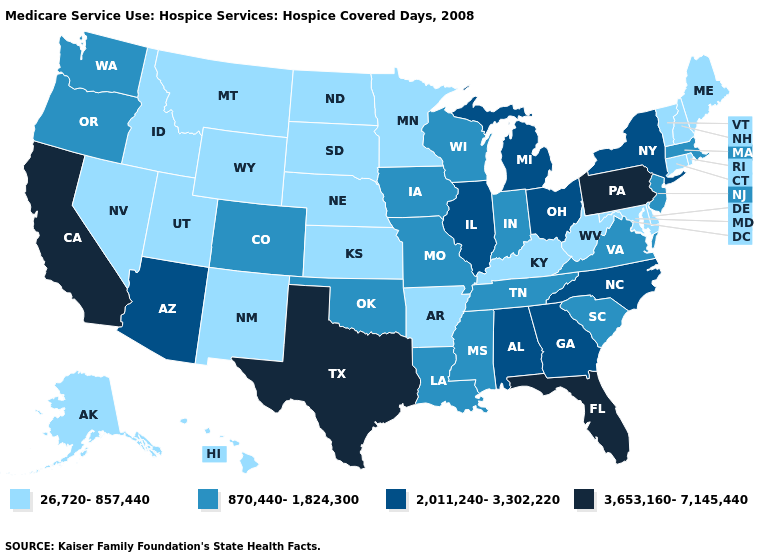Name the states that have a value in the range 26,720-857,440?
Quick response, please. Alaska, Arkansas, Connecticut, Delaware, Hawaii, Idaho, Kansas, Kentucky, Maine, Maryland, Minnesota, Montana, Nebraska, Nevada, New Hampshire, New Mexico, North Dakota, Rhode Island, South Dakota, Utah, Vermont, West Virginia, Wyoming. What is the lowest value in states that border Missouri?
Give a very brief answer. 26,720-857,440. Name the states that have a value in the range 870,440-1,824,300?
Write a very short answer. Colorado, Indiana, Iowa, Louisiana, Massachusetts, Mississippi, Missouri, New Jersey, Oklahoma, Oregon, South Carolina, Tennessee, Virginia, Washington, Wisconsin. What is the value of New Jersey?
Answer briefly. 870,440-1,824,300. Does Mississippi have the lowest value in the USA?
Write a very short answer. No. What is the value of Maryland?
Short answer required. 26,720-857,440. Name the states that have a value in the range 2,011,240-3,302,220?
Concise answer only. Alabama, Arizona, Georgia, Illinois, Michigan, New York, North Carolina, Ohio. Which states have the highest value in the USA?
Keep it brief. California, Florida, Pennsylvania, Texas. Name the states that have a value in the range 870,440-1,824,300?
Concise answer only. Colorado, Indiana, Iowa, Louisiana, Massachusetts, Mississippi, Missouri, New Jersey, Oklahoma, Oregon, South Carolina, Tennessee, Virginia, Washington, Wisconsin. Name the states that have a value in the range 3,653,160-7,145,440?
Concise answer only. California, Florida, Pennsylvania, Texas. Name the states that have a value in the range 870,440-1,824,300?
Short answer required. Colorado, Indiana, Iowa, Louisiana, Massachusetts, Mississippi, Missouri, New Jersey, Oklahoma, Oregon, South Carolina, Tennessee, Virginia, Washington, Wisconsin. Name the states that have a value in the range 26,720-857,440?
Concise answer only. Alaska, Arkansas, Connecticut, Delaware, Hawaii, Idaho, Kansas, Kentucky, Maine, Maryland, Minnesota, Montana, Nebraska, Nevada, New Hampshire, New Mexico, North Dakota, Rhode Island, South Dakota, Utah, Vermont, West Virginia, Wyoming. Does Georgia have the same value as Colorado?
Concise answer only. No. How many symbols are there in the legend?
Concise answer only. 4. Name the states that have a value in the range 26,720-857,440?
Concise answer only. Alaska, Arkansas, Connecticut, Delaware, Hawaii, Idaho, Kansas, Kentucky, Maine, Maryland, Minnesota, Montana, Nebraska, Nevada, New Hampshire, New Mexico, North Dakota, Rhode Island, South Dakota, Utah, Vermont, West Virginia, Wyoming. 